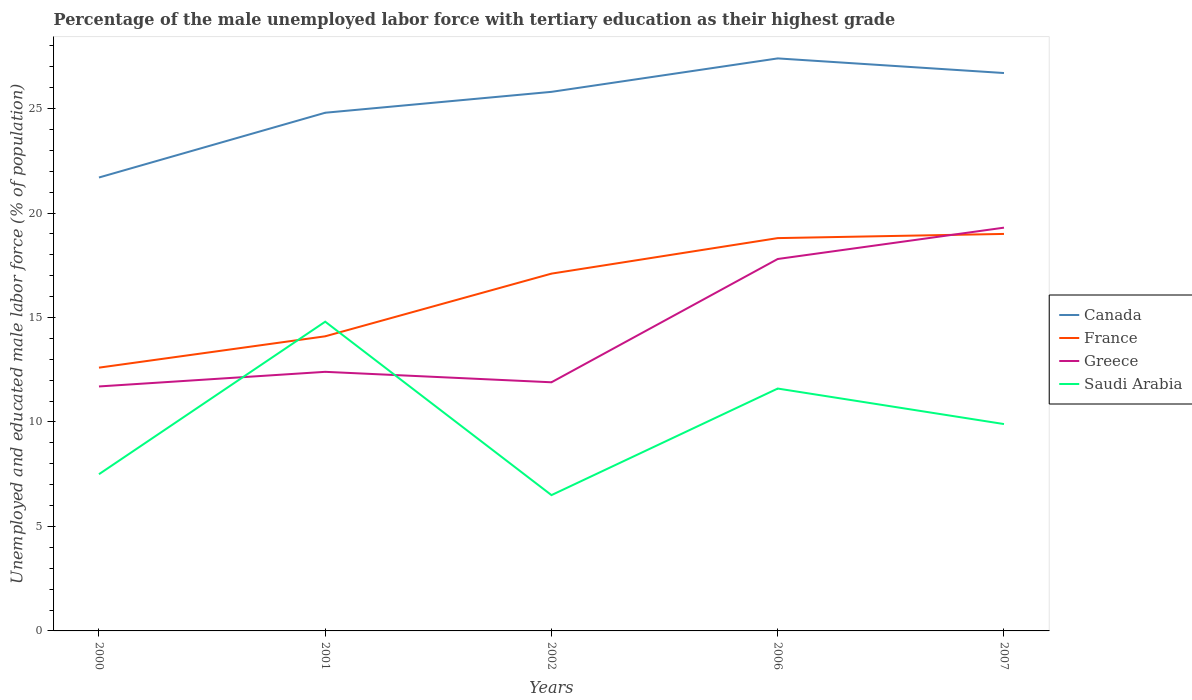Does the line corresponding to France intersect with the line corresponding to Greece?
Provide a succinct answer. Yes. What is the total percentage of the unemployed male labor force with tertiary education in France in the graph?
Make the answer very short. -6.4. What is the difference between the highest and the second highest percentage of the unemployed male labor force with tertiary education in Saudi Arabia?
Your response must be concise. 8.3. Does the graph contain any zero values?
Provide a short and direct response. No. How many legend labels are there?
Offer a very short reply. 4. How are the legend labels stacked?
Your answer should be very brief. Vertical. What is the title of the graph?
Provide a short and direct response. Percentage of the male unemployed labor force with tertiary education as their highest grade. What is the label or title of the X-axis?
Provide a succinct answer. Years. What is the label or title of the Y-axis?
Offer a very short reply. Unemployed and educated male labor force (% of population). What is the Unemployed and educated male labor force (% of population) of Canada in 2000?
Your answer should be very brief. 21.7. What is the Unemployed and educated male labor force (% of population) in France in 2000?
Make the answer very short. 12.6. What is the Unemployed and educated male labor force (% of population) of Greece in 2000?
Provide a short and direct response. 11.7. What is the Unemployed and educated male labor force (% of population) in Saudi Arabia in 2000?
Offer a very short reply. 7.5. What is the Unemployed and educated male labor force (% of population) of Canada in 2001?
Keep it short and to the point. 24.8. What is the Unemployed and educated male labor force (% of population) of France in 2001?
Provide a short and direct response. 14.1. What is the Unemployed and educated male labor force (% of population) in Greece in 2001?
Offer a very short reply. 12.4. What is the Unemployed and educated male labor force (% of population) in Saudi Arabia in 2001?
Your answer should be compact. 14.8. What is the Unemployed and educated male labor force (% of population) in Canada in 2002?
Your answer should be very brief. 25.8. What is the Unemployed and educated male labor force (% of population) of France in 2002?
Ensure brevity in your answer.  17.1. What is the Unemployed and educated male labor force (% of population) of Greece in 2002?
Give a very brief answer. 11.9. What is the Unemployed and educated male labor force (% of population) in Canada in 2006?
Your response must be concise. 27.4. What is the Unemployed and educated male labor force (% of population) in France in 2006?
Your answer should be very brief. 18.8. What is the Unemployed and educated male labor force (% of population) of Greece in 2006?
Provide a short and direct response. 17.8. What is the Unemployed and educated male labor force (% of population) in Saudi Arabia in 2006?
Provide a short and direct response. 11.6. What is the Unemployed and educated male labor force (% of population) in Canada in 2007?
Offer a terse response. 26.7. What is the Unemployed and educated male labor force (% of population) in France in 2007?
Give a very brief answer. 19. What is the Unemployed and educated male labor force (% of population) in Greece in 2007?
Offer a terse response. 19.3. What is the Unemployed and educated male labor force (% of population) in Saudi Arabia in 2007?
Your answer should be very brief. 9.9. Across all years, what is the maximum Unemployed and educated male labor force (% of population) of Canada?
Your answer should be compact. 27.4. Across all years, what is the maximum Unemployed and educated male labor force (% of population) of Greece?
Make the answer very short. 19.3. Across all years, what is the maximum Unemployed and educated male labor force (% of population) in Saudi Arabia?
Your response must be concise. 14.8. Across all years, what is the minimum Unemployed and educated male labor force (% of population) in Canada?
Your answer should be compact. 21.7. Across all years, what is the minimum Unemployed and educated male labor force (% of population) of France?
Offer a terse response. 12.6. Across all years, what is the minimum Unemployed and educated male labor force (% of population) of Greece?
Offer a terse response. 11.7. What is the total Unemployed and educated male labor force (% of population) in Canada in the graph?
Provide a succinct answer. 126.4. What is the total Unemployed and educated male labor force (% of population) in France in the graph?
Make the answer very short. 81.6. What is the total Unemployed and educated male labor force (% of population) in Greece in the graph?
Your answer should be compact. 73.1. What is the total Unemployed and educated male labor force (% of population) of Saudi Arabia in the graph?
Keep it short and to the point. 50.3. What is the difference between the Unemployed and educated male labor force (% of population) in Canada in 2000 and that in 2001?
Keep it short and to the point. -3.1. What is the difference between the Unemployed and educated male labor force (% of population) of France in 2000 and that in 2001?
Make the answer very short. -1.5. What is the difference between the Unemployed and educated male labor force (% of population) in Canada in 2000 and that in 2002?
Provide a succinct answer. -4.1. What is the difference between the Unemployed and educated male labor force (% of population) in Saudi Arabia in 2000 and that in 2006?
Your response must be concise. -4.1. What is the difference between the Unemployed and educated male labor force (% of population) of Canada in 2000 and that in 2007?
Your answer should be very brief. -5. What is the difference between the Unemployed and educated male labor force (% of population) of France in 2000 and that in 2007?
Offer a very short reply. -6.4. What is the difference between the Unemployed and educated male labor force (% of population) of Greece in 2000 and that in 2007?
Give a very brief answer. -7.6. What is the difference between the Unemployed and educated male labor force (% of population) in Saudi Arabia in 2000 and that in 2007?
Offer a terse response. -2.4. What is the difference between the Unemployed and educated male labor force (% of population) of Canada in 2001 and that in 2002?
Your answer should be very brief. -1. What is the difference between the Unemployed and educated male labor force (% of population) of Saudi Arabia in 2001 and that in 2002?
Offer a very short reply. 8.3. What is the difference between the Unemployed and educated male labor force (% of population) of Canada in 2001 and that in 2006?
Provide a succinct answer. -2.6. What is the difference between the Unemployed and educated male labor force (% of population) of Greece in 2001 and that in 2006?
Your answer should be very brief. -5.4. What is the difference between the Unemployed and educated male labor force (% of population) in Saudi Arabia in 2001 and that in 2006?
Make the answer very short. 3.2. What is the difference between the Unemployed and educated male labor force (% of population) in Greece in 2001 and that in 2007?
Ensure brevity in your answer.  -6.9. What is the difference between the Unemployed and educated male labor force (% of population) of Saudi Arabia in 2001 and that in 2007?
Keep it short and to the point. 4.9. What is the difference between the Unemployed and educated male labor force (% of population) in France in 2002 and that in 2006?
Provide a short and direct response. -1.7. What is the difference between the Unemployed and educated male labor force (% of population) in Greece in 2002 and that in 2006?
Provide a succinct answer. -5.9. What is the difference between the Unemployed and educated male labor force (% of population) in Saudi Arabia in 2002 and that in 2006?
Keep it short and to the point. -5.1. What is the difference between the Unemployed and educated male labor force (% of population) in France in 2002 and that in 2007?
Provide a short and direct response. -1.9. What is the difference between the Unemployed and educated male labor force (% of population) in Saudi Arabia in 2002 and that in 2007?
Give a very brief answer. -3.4. What is the difference between the Unemployed and educated male labor force (% of population) of Canada in 2006 and that in 2007?
Your answer should be compact. 0.7. What is the difference between the Unemployed and educated male labor force (% of population) of Saudi Arabia in 2006 and that in 2007?
Ensure brevity in your answer.  1.7. What is the difference between the Unemployed and educated male labor force (% of population) in Canada in 2000 and the Unemployed and educated male labor force (% of population) in Greece in 2001?
Make the answer very short. 9.3. What is the difference between the Unemployed and educated male labor force (% of population) of Canada in 2000 and the Unemployed and educated male labor force (% of population) of Saudi Arabia in 2001?
Offer a very short reply. 6.9. What is the difference between the Unemployed and educated male labor force (% of population) of France in 2000 and the Unemployed and educated male labor force (% of population) of Greece in 2001?
Your answer should be very brief. 0.2. What is the difference between the Unemployed and educated male labor force (% of population) of France in 2000 and the Unemployed and educated male labor force (% of population) of Saudi Arabia in 2001?
Your response must be concise. -2.2. What is the difference between the Unemployed and educated male labor force (% of population) of Canada in 2000 and the Unemployed and educated male labor force (% of population) of France in 2002?
Give a very brief answer. 4.6. What is the difference between the Unemployed and educated male labor force (% of population) of Canada in 2000 and the Unemployed and educated male labor force (% of population) of Greece in 2002?
Offer a very short reply. 9.8. What is the difference between the Unemployed and educated male labor force (% of population) of France in 2000 and the Unemployed and educated male labor force (% of population) of Saudi Arabia in 2002?
Give a very brief answer. 6.1. What is the difference between the Unemployed and educated male labor force (% of population) in Greece in 2000 and the Unemployed and educated male labor force (% of population) in Saudi Arabia in 2002?
Provide a succinct answer. 5.2. What is the difference between the Unemployed and educated male labor force (% of population) in Canada in 2000 and the Unemployed and educated male labor force (% of population) in France in 2006?
Ensure brevity in your answer.  2.9. What is the difference between the Unemployed and educated male labor force (% of population) in Canada in 2000 and the Unemployed and educated male labor force (% of population) in Saudi Arabia in 2006?
Offer a terse response. 10.1. What is the difference between the Unemployed and educated male labor force (% of population) of France in 2000 and the Unemployed and educated male labor force (% of population) of Greece in 2006?
Keep it short and to the point. -5.2. What is the difference between the Unemployed and educated male labor force (% of population) of Greece in 2000 and the Unemployed and educated male labor force (% of population) of Saudi Arabia in 2006?
Make the answer very short. 0.1. What is the difference between the Unemployed and educated male labor force (% of population) in Canada in 2000 and the Unemployed and educated male labor force (% of population) in France in 2007?
Your answer should be very brief. 2.7. What is the difference between the Unemployed and educated male labor force (% of population) in Canada in 2000 and the Unemployed and educated male labor force (% of population) in Greece in 2007?
Your answer should be very brief. 2.4. What is the difference between the Unemployed and educated male labor force (% of population) in France in 2000 and the Unemployed and educated male labor force (% of population) in Greece in 2007?
Provide a short and direct response. -6.7. What is the difference between the Unemployed and educated male labor force (% of population) of Greece in 2000 and the Unemployed and educated male labor force (% of population) of Saudi Arabia in 2007?
Provide a short and direct response. 1.8. What is the difference between the Unemployed and educated male labor force (% of population) of Canada in 2001 and the Unemployed and educated male labor force (% of population) of France in 2002?
Your answer should be very brief. 7.7. What is the difference between the Unemployed and educated male labor force (% of population) of Canada in 2001 and the Unemployed and educated male labor force (% of population) of Saudi Arabia in 2002?
Give a very brief answer. 18.3. What is the difference between the Unemployed and educated male labor force (% of population) of France in 2001 and the Unemployed and educated male labor force (% of population) of Saudi Arabia in 2002?
Ensure brevity in your answer.  7.6. What is the difference between the Unemployed and educated male labor force (% of population) in Greece in 2001 and the Unemployed and educated male labor force (% of population) in Saudi Arabia in 2002?
Provide a succinct answer. 5.9. What is the difference between the Unemployed and educated male labor force (% of population) in Canada in 2001 and the Unemployed and educated male labor force (% of population) in Greece in 2006?
Make the answer very short. 7. What is the difference between the Unemployed and educated male labor force (% of population) of Canada in 2001 and the Unemployed and educated male labor force (% of population) of Saudi Arabia in 2006?
Provide a short and direct response. 13.2. What is the difference between the Unemployed and educated male labor force (% of population) in Greece in 2001 and the Unemployed and educated male labor force (% of population) in Saudi Arabia in 2006?
Keep it short and to the point. 0.8. What is the difference between the Unemployed and educated male labor force (% of population) in Greece in 2001 and the Unemployed and educated male labor force (% of population) in Saudi Arabia in 2007?
Ensure brevity in your answer.  2.5. What is the difference between the Unemployed and educated male labor force (% of population) of Canada in 2002 and the Unemployed and educated male labor force (% of population) of France in 2006?
Make the answer very short. 7. What is the difference between the Unemployed and educated male labor force (% of population) in Canada in 2002 and the Unemployed and educated male labor force (% of population) in Greece in 2006?
Your answer should be compact. 8. What is the difference between the Unemployed and educated male labor force (% of population) in France in 2002 and the Unemployed and educated male labor force (% of population) in Greece in 2006?
Offer a very short reply. -0.7. What is the difference between the Unemployed and educated male labor force (% of population) in France in 2002 and the Unemployed and educated male labor force (% of population) in Saudi Arabia in 2006?
Your answer should be very brief. 5.5. What is the difference between the Unemployed and educated male labor force (% of population) in Greece in 2002 and the Unemployed and educated male labor force (% of population) in Saudi Arabia in 2006?
Give a very brief answer. 0.3. What is the difference between the Unemployed and educated male labor force (% of population) in Canada in 2002 and the Unemployed and educated male labor force (% of population) in France in 2007?
Provide a succinct answer. 6.8. What is the difference between the Unemployed and educated male labor force (% of population) in Canada in 2002 and the Unemployed and educated male labor force (% of population) in Greece in 2007?
Offer a terse response. 6.5. What is the difference between the Unemployed and educated male labor force (% of population) of Canada in 2006 and the Unemployed and educated male labor force (% of population) of Saudi Arabia in 2007?
Provide a succinct answer. 17.5. What is the difference between the Unemployed and educated male labor force (% of population) of France in 2006 and the Unemployed and educated male labor force (% of population) of Saudi Arabia in 2007?
Give a very brief answer. 8.9. What is the difference between the Unemployed and educated male labor force (% of population) in Greece in 2006 and the Unemployed and educated male labor force (% of population) in Saudi Arabia in 2007?
Ensure brevity in your answer.  7.9. What is the average Unemployed and educated male labor force (% of population) in Canada per year?
Offer a very short reply. 25.28. What is the average Unemployed and educated male labor force (% of population) of France per year?
Provide a succinct answer. 16.32. What is the average Unemployed and educated male labor force (% of population) of Greece per year?
Ensure brevity in your answer.  14.62. What is the average Unemployed and educated male labor force (% of population) of Saudi Arabia per year?
Your response must be concise. 10.06. In the year 2000, what is the difference between the Unemployed and educated male labor force (% of population) in Canada and Unemployed and educated male labor force (% of population) in Saudi Arabia?
Give a very brief answer. 14.2. In the year 2000, what is the difference between the Unemployed and educated male labor force (% of population) in Greece and Unemployed and educated male labor force (% of population) in Saudi Arabia?
Keep it short and to the point. 4.2. In the year 2001, what is the difference between the Unemployed and educated male labor force (% of population) of Canada and Unemployed and educated male labor force (% of population) of Saudi Arabia?
Keep it short and to the point. 10. In the year 2001, what is the difference between the Unemployed and educated male labor force (% of population) of France and Unemployed and educated male labor force (% of population) of Greece?
Give a very brief answer. 1.7. In the year 2002, what is the difference between the Unemployed and educated male labor force (% of population) in Canada and Unemployed and educated male labor force (% of population) in France?
Ensure brevity in your answer.  8.7. In the year 2002, what is the difference between the Unemployed and educated male labor force (% of population) of Canada and Unemployed and educated male labor force (% of population) of Saudi Arabia?
Your answer should be compact. 19.3. In the year 2002, what is the difference between the Unemployed and educated male labor force (% of population) of Greece and Unemployed and educated male labor force (% of population) of Saudi Arabia?
Keep it short and to the point. 5.4. In the year 2006, what is the difference between the Unemployed and educated male labor force (% of population) of Canada and Unemployed and educated male labor force (% of population) of France?
Your answer should be very brief. 8.6. In the year 2006, what is the difference between the Unemployed and educated male labor force (% of population) of Canada and Unemployed and educated male labor force (% of population) of Greece?
Your response must be concise. 9.6. In the year 2006, what is the difference between the Unemployed and educated male labor force (% of population) of Canada and Unemployed and educated male labor force (% of population) of Saudi Arabia?
Give a very brief answer. 15.8. In the year 2006, what is the difference between the Unemployed and educated male labor force (% of population) in France and Unemployed and educated male labor force (% of population) in Greece?
Provide a short and direct response. 1. In the year 2006, what is the difference between the Unemployed and educated male labor force (% of population) of France and Unemployed and educated male labor force (% of population) of Saudi Arabia?
Keep it short and to the point. 7.2. In the year 2006, what is the difference between the Unemployed and educated male labor force (% of population) of Greece and Unemployed and educated male labor force (% of population) of Saudi Arabia?
Your answer should be compact. 6.2. In the year 2007, what is the difference between the Unemployed and educated male labor force (% of population) in France and Unemployed and educated male labor force (% of population) in Saudi Arabia?
Keep it short and to the point. 9.1. What is the ratio of the Unemployed and educated male labor force (% of population) of Canada in 2000 to that in 2001?
Your answer should be very brief. 0.88. What is the ratio of the Unemployed and educated male labor force (% of population) of France in 2000 to that in 2001?
Give a very brief answer. 0.89. What is the ratio of the Unemployed and educated male labor force (% of population) in Greece in 2000 to that in 2001?
Keep it short and to the point. 0.94. What is the ratio of the Unemployed and educated male labor force (% of population) of Saudi Arabia in 2000 to that in 2001?
Offer a terse response. 0.51. What is the ratio of the Unemployed and educated male labor force (% of population) of Canada in 2000 to that in 2002?
Provide a succinct answer. 0.84. What is the ratio of the Unemployed and educated male labor force (% of population) of France in 2000 to that in 2002?
Give a very brief answer. 0.74. What is the ratio of the Unemployed and educated male labor force (% of population) of Greece in 2000 to that in 2002?
Keep it short and to the point. 0.98. What is the ratio of the Unemployed and educated male labor force (% of population) in Saudi Arabia in 2000 to that in 2002?
Offer a very short reply. 1.15. What is the ratio of the Unemployed and educated male labor force (% of population) in Canada in 2000 to that in 2006?
Your response must be concise. 0.79. What is the ratio of the Unemployed and educated male labor force (% of population) in France in 2000 to that in 2006?
Your answer should be compact. 0.67. What is the ratio of the Unemployed and educated male labor force (% of population) of Greece in 2000 to that in 2006?
Your response must be concise. 0.66. What is the ratio of the Unemployed and educated male labor force (% of population) of Saudi Arabia in 2000 to that in 2006?
Give a very brief answer. 0.65. What is the ratio of the Unemployed and educated male labor force (% of population) in Canada in 2000 to that in 2007?
Provide a succinct answer. 0.81. What is the ratio of the Unemployed and educated male labor force (% of population) in France in 2000 to that in 2007?
Offer a very short reply. 0.66. What is the ratio of the Unemployed and educated male labor force (% of population) in Greece in 2000 to that in 2007?
Offer a terse response. 0.61. What is the ratio of the Unemployed and educated male labor force (% of population) in Saudi Arabia in 2000 to that in 2007?
Your answer should be compact. 0.76. What is the ratio of the Unemployed and educated male labor force (% of population) in Canada in 2001 to that in 2002?
Provide a succinct answer. 0.96. What is the ratio of the Unemployed and educated male labor force (% of population) in France in 2001 to that in 2002?
Make the answer very short. 0.82. What is the ratio of the Unemployed and educated male labor force (% of population) in Greece in 2001 to that in 2002?
Keep it short and to the point. 1.04. What is the ratio of the Unemployed and educated male labor force (% of population) of Saudi Arabia in 2001 to that in 2002?
Make the answer very short. 2.28. What is the ratio of the Unemployed and educated male labor force (% of population) in Canada in 2001 to that in 2006?
Your answer should be compact. 0.91. What is the ratio of the Unemployed and educated male labor force (% of population) of Greece in 2001 to that in 2006?
Keep it short and to the point. 0.7. What is the ratio of the Unemployed and educated male labor force (% of population) in Saudi Arabia in 2001 to that in 2006?
Keep it short and to the point. 1.28. What is the ratio of the Unemployed and educated male labor force (% of population) in Canada in 2001 to that in 2007?
Provide a succinct answer. 0.93. What is the ratio of the Unemployed and educated male labor force (% of population) of France in 2001 to that in 2007?
Give a very brief answer. 0.74. What is the ratio of the Unemployed and educated male labor force (% of population) of Greece in 2001 to that in 2007?
Ensure brevity in your answer.  0.64. What is the ratio of the Unemployed and educated male labor force (% of population) of Saudi Arabia in 2001 to that in 2007?
Keep it short and to the point. 1.49. What is the ratio of the Unemployed and educated male labor force (% of population) of Canada in 2002 to that in 2006?
Provide a succinct answer. 0.94. What is the ratio of the Unemployed and educated male labor force (% of population) in France in 2002 to that in 2006?
Make the answer very short. 0.91. What is the ratio of the Unemployed and educated male labor force (% of population) of Greece in 2002 to that in 2006?
Your response must be concise. 0.67. What is the ratio of the Unemployed and educated male labor force (% of population) of Saudi Arabia in 2002 to that in 2006?
Your response must be concise. 0.56. What is the ratio of the Unemployed and educated male labor force (% of population) in Canada in 2002 to that in 2007?
Your answer should be compact. 0.97. What is the ratio of the Unemployed and educated male labor force (% of population) in France in 2002 to that in 2007?
Provide a succinct answer. 0.9. What is the ratio of the Unemployed and educated male labor force (% of population) of Greece in 2002 to that in 2007?
Ensure brevity in your answer.  0.62. What is the ratio of the Unemployed and educated male labor force (% of population) of Saudi Arabia in 2002 to that in 2007?
Provide a short and direct response. 0.66. What is the ratio of the Unemployed and educated male labor force (% of population) in Canada in 2006 to that in 2007?
Give a very brief answer. 1.03. What is the ratio of the Unemployed and educated male labor force (% of population) of France in 2006 to that in 2007?
Make the answer very short. 0.99. What is the ratio of the Unemployed and educated male labor force (% of population) in Greece in 2006 to that in 2007?
Make the answer very short. 0.92. What is the ratio of the Unemployed and educated male labor force (% of population) of Saudi Arabia in 2006 to that in 2007?
Your answer should be compact. 1.17. What is the difference between the highest and the second highest Unemployed and educated male labor force (% of population) in France?
Your answer should be compact. 0.2. What is the difference between the highest and the lowest Unemployed and educated male labor force (% of population) in France?
Offer a terse response. 6.4. What is the difference between the highest and the lowest Unemployed and educated male labor force (% of population) in Saudi Arabia?
Provide a succinct answer. 8.3. 